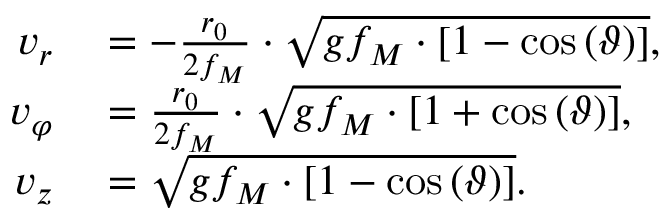<formula> <loc_0><loc_0><loc_500><loc_500>\begin{array} { r l } { v _ { r } } & = - \frac { r _ { 0 } } { 2 f _ { M } } \cdot \sqrt { g f _ { M } \cdot \left [ 1 - \cos \left ( \vartheta \right ) \right ] } , } \\ { v _ { \varphi } } & = \frac { r _ { 0 } } { 2 f _ { M } } \cdot \sqrt { g f _ { M } \cdot \left [ 1 + \cos \left ( \vartheta \right ) \right ] } , } \\ { v _ { z } } & = \sqrt { g f _ { M } \cdot \left [ 1 - \cos \left ( \vartheta \right ) \right ] } . } \end{array}</formula> 